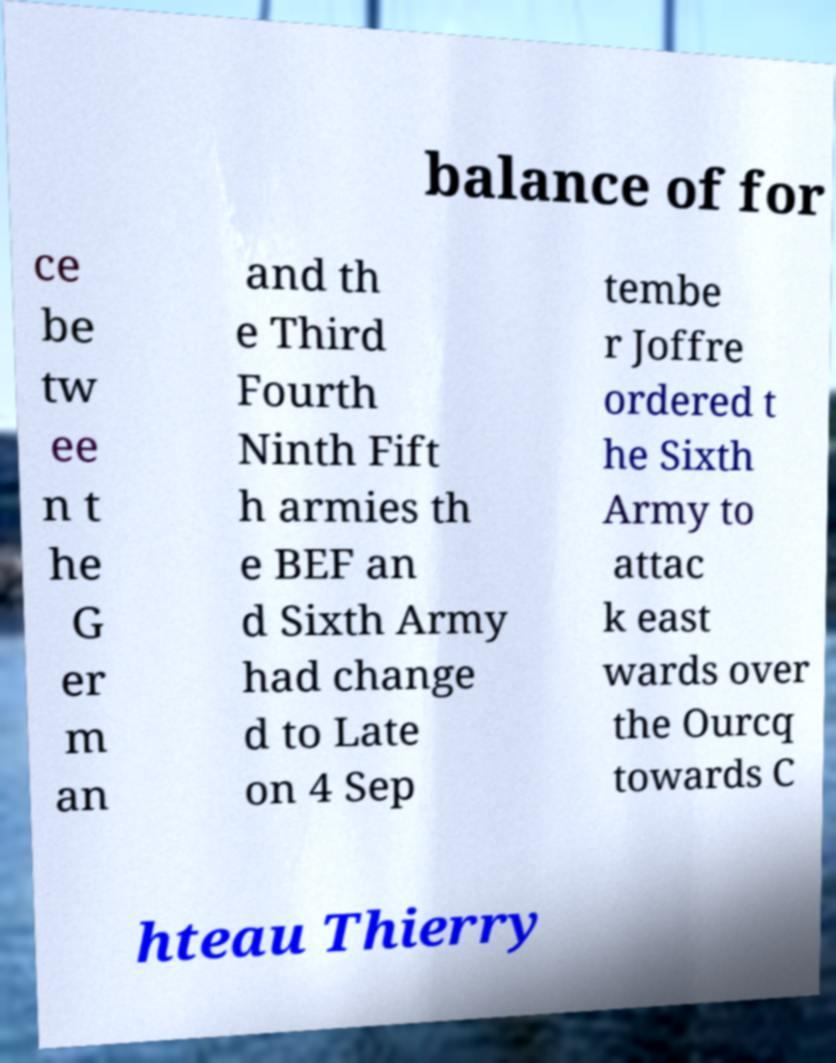For documentation purposes, I need the text within this image transcribed. Could you provide that? balance of for ce be tw ee n t he G er m an and th e Third Fourth Ninth Fift h armies th e BEF an d Sixth Army had change d to Late on 4 Sep tembe r Joffre ordered t he Sixth Army to attac k east wards over the Ourcq towards C hteau Thierry 